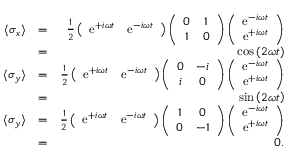<formula> <loc_0><loc_0><loc_500><loc_500>\begin{array} { r l r } { \langle \sigma _ { x } \rangle } & { = } & { \frac { 1 } { 2 } \left ( \begin{array} { c c } { e ^ { + i \omega t } } & { e ^ { - i \omega t } } \end{array} \right ) \left ( \begin{array} { c c } { 0 } & { 1 } \\ { 1 } & { 0 } \end{array} \right ) \left ( \begin{array} { c } { e ^ { - i \omega t } } \\ { e ^ { + i \omega t } } \end{array} \right ) } \\ & { = } & { \cos \left ( 2 \omega t \right ) } \\ { \langle \sigma _ { y } \rangle } & { = } & { \frac { 1 } { 2 } \left ( \begin{array} { c c } { e ^ { + i \omega t } } & { e ^ { - i \omega t } } \end{array} \right ) \left ( \begin{array} { c c } { 0 } & { - i } \\ { i } & { 0 } \end{array} \right ) \left ( \begin{array} { c } { e ^ { - i \omega t } } \\ { e ^ { + i \omega t } } \end{array} \right ) } \\ & { = } & { \sin \left ( 2 \omega t \right ) } \\ { \langle \sigma _ { y } \rangle } & { = } & { \frac { 1 } { 2 } \left ( \begin{array} { c c } { e ^ { + i \omega t } } & { e ^ { - i \omega t } } \end{array} \right ) \left ( \begin{array} { c c } { 1 } & { 0 } \\ { 0 } & { - 1 } \end{array} \right ) \left ( \begin{array} { c } { e ^ { - i \omega t } } \\ { e ^ { + i \omega t } } \end{array} \right ) } \\ & { = } & { 0 . } \end{array}</formula> 